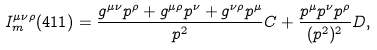Convert formula to latex. <formula><loc_0><loc_0><loc_500><loc_500>I ^ { \mu \nu \rho } _ { m } ( 4 1 1 ) = \frac { g ^ { \mu \nu } p ^ { \rho } + g ^ { \mu \rho } p ^ { \nu } + g ^ { \nu \rho } p ^ { \mu } } { p ^ { 2 } } C + \frac { p ^ { \mu } p ^ { \nu } p ^ { \rho } } { ( p ^ { 2 } ) ^ { 2 } } D ,</formula> 